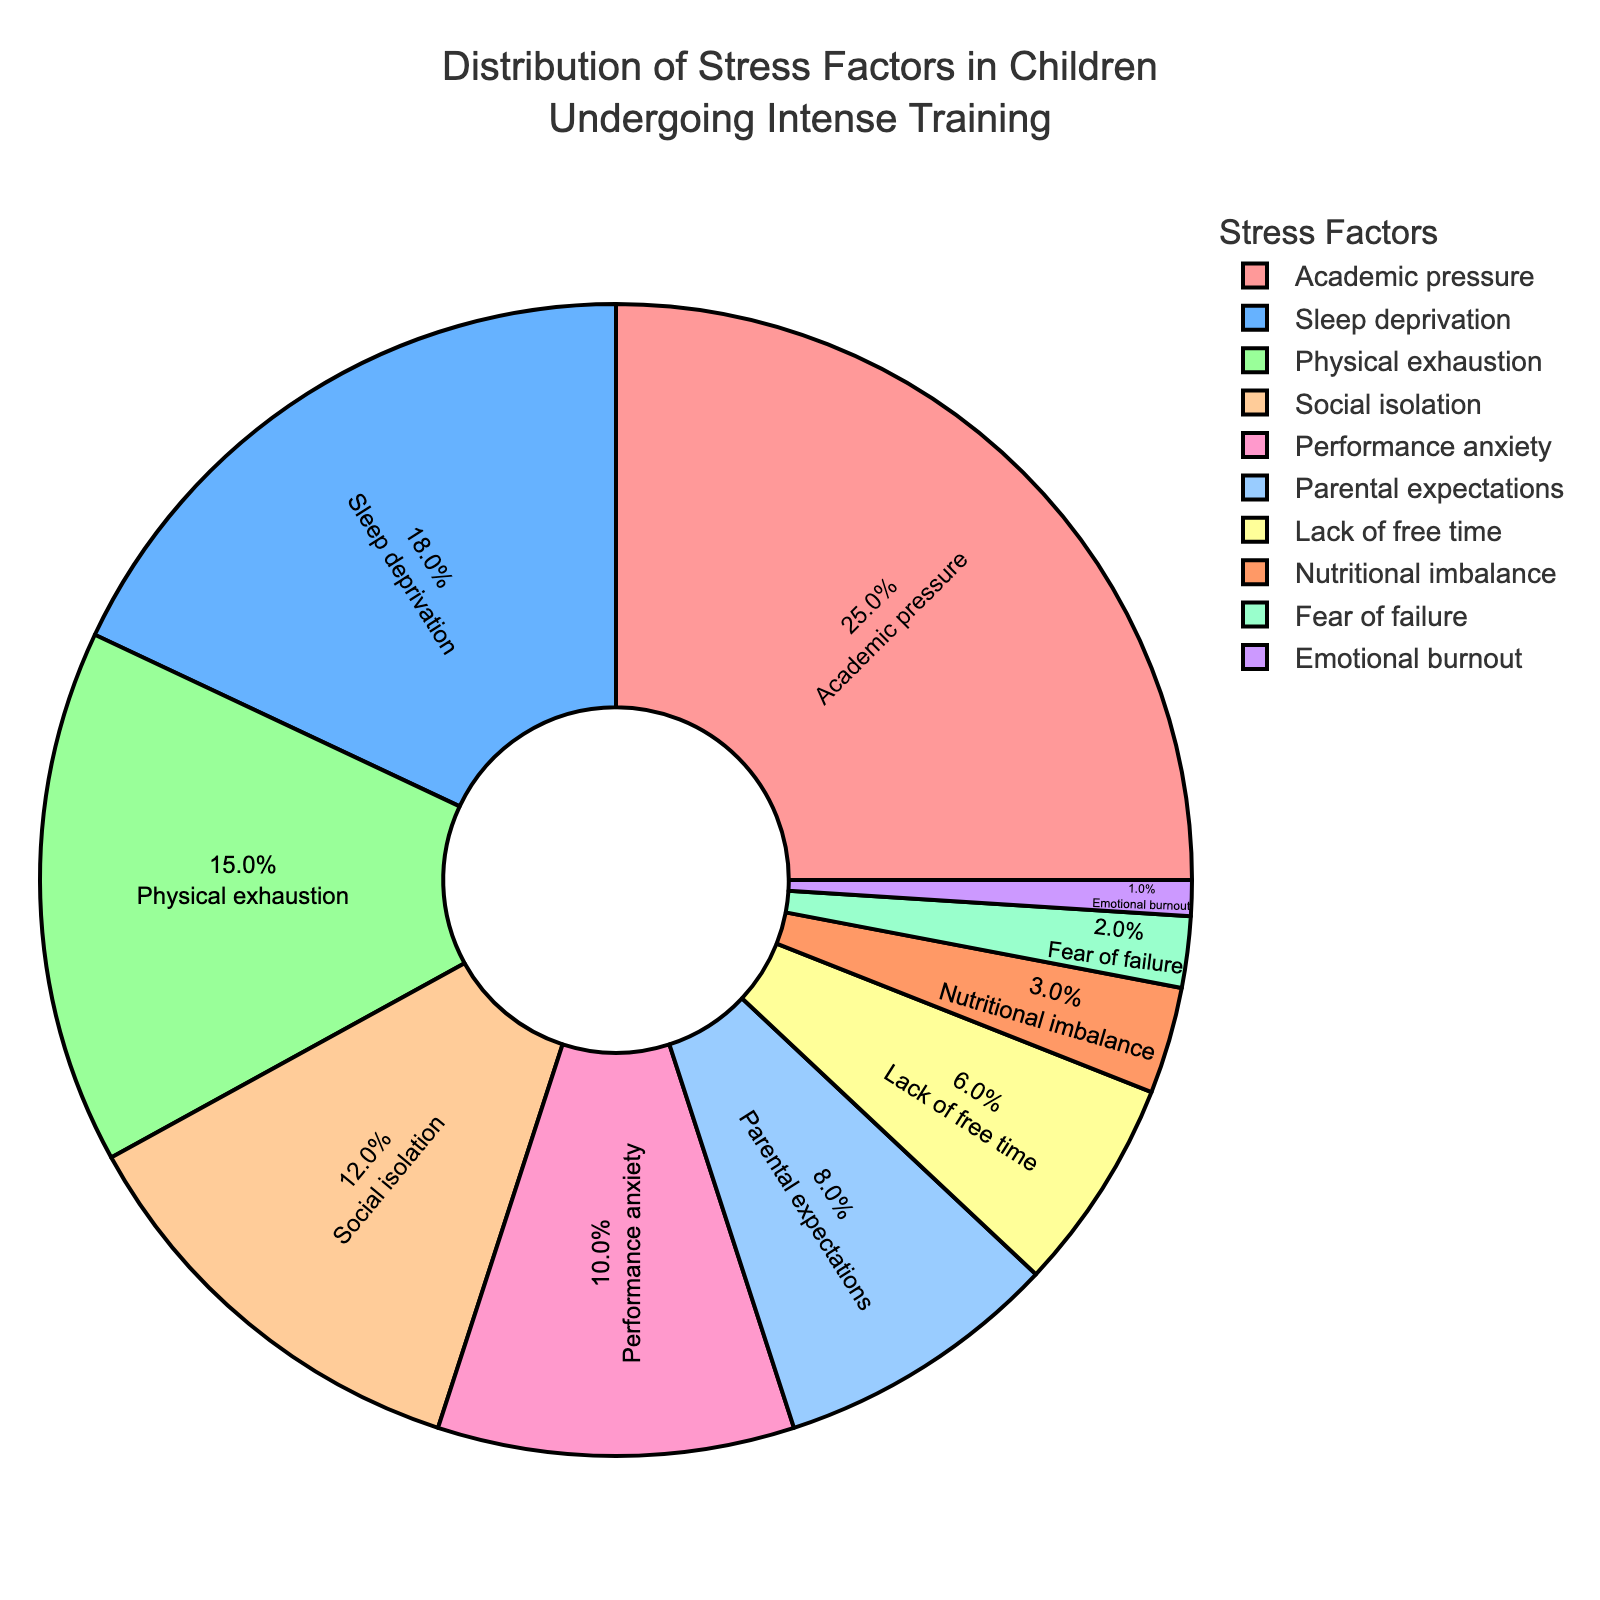Which stress factor accounts for the largest percentage? Find the largest section of the pie chart by determining which label has the highest percentage.
Answer: Academic pressure What is the total percentage contributed by Performance anxiety and Lack of free time? Identify the sections labeled "Performance anxiety" and "Lack of free time" and sum their percentages (10% + 6%).
Answer: 16% Which stress factor is indicated by the red color? Locate the section colored in red and read its corresponding label.
Answer: Academic pressure How much more percentage is Physical exhaustion compared to Fear of failure? Subtract the percentage of Fear of failure (2%) from Physical exhaustion (15%) to find the difference (15% - 2%).
Answer: 13% What is the combined percentage of factors contributing less than 10% each? Add the percentages of all sections with less than 10%: Parental expectations (8%), Lack of free time (6%), Nutritional imbalance (3%), Fear of failure (2%), Emotional burnout (1%) (8% + 6% + 3% + 2% + 1%).
Answer: 20% Which stress factor has a percentage double that of Social isolation? Social isolation has 12%, and we need a factor with ~24%. The closest factor with half as many in the opposite direction is Academic pressure.
Answer: None Which stress factor contributes the smallest percentage to the total stress distribution? Find the smallest section of the pie chart by determining which label has the lowest percentage.
Answer: Emotional burnout Is the percentage of Academic pressure greater than the sum of Sleep deprivation and Physical exhaustion? Compare the percentage of Academic pressure (25%) with the sum of Sleep deprivation (18%) and Physical exhaustion (15%) by adding them (18% + 15% = 33%).
Answer: No What is the difference in percentage between Social isolation and Parental expectations? Subtract the percentage of Parental expectations (8%) from Social isolation (12%) to find the difference (12% - 8%).
Answer: 4% 